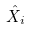Convert formula to latex. <formula><loc_0><loc_0><loc_500><loc_500>\hat { X } _ { i }</formula> 